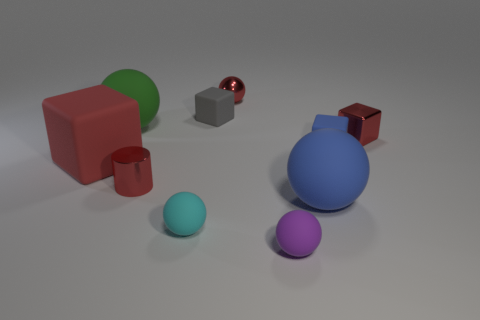Can you tell me what objects are present in the scene and their colors? Certainly! The image displays a variety of geometric objects. There is a large blue sphere, a smaller cyan sphere, and two purple spheres, one of which is notably smaller than the other. Additionally, there is a green sphere, a red cube, two brown cubes—one dark, one light—and a silver cuboid. 